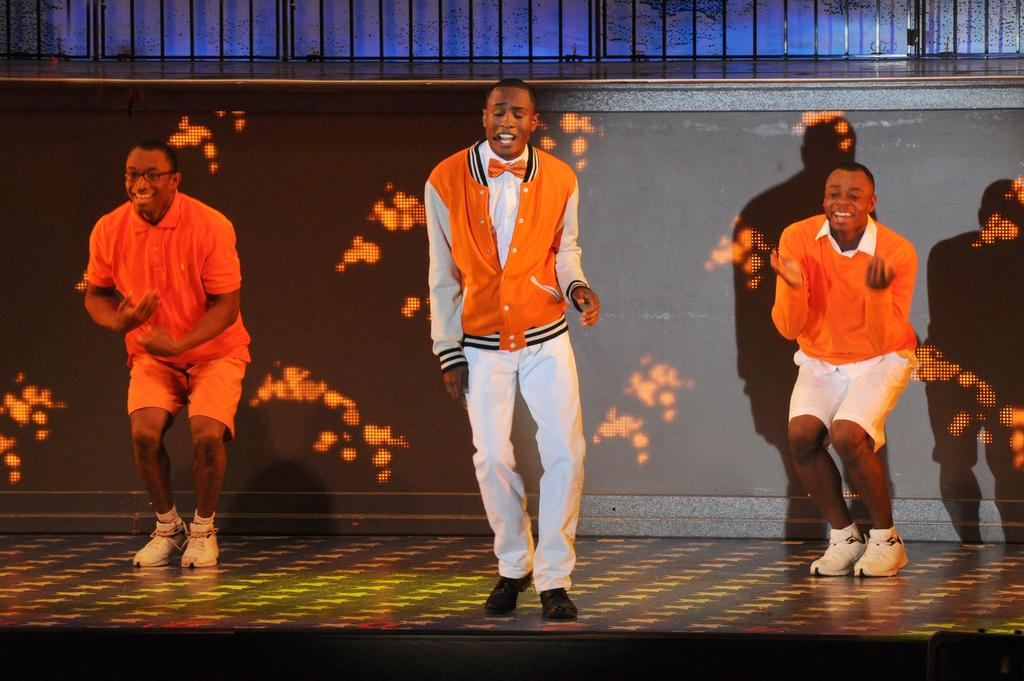How many people are in the image? There are three people in the image. What are the people doing in the image? The people are dancing on the floor. What can be seen behind the people? There appears to be a screen behind the people. What architectural feature is visible at the top of the image? Iron grilles are visible at the top of the image. What type of meat is being cooked on the stove in the image? There is no stove or meat present in the image; it features three people dancing on the floor with a screen behind them and iron grilles at the top. 